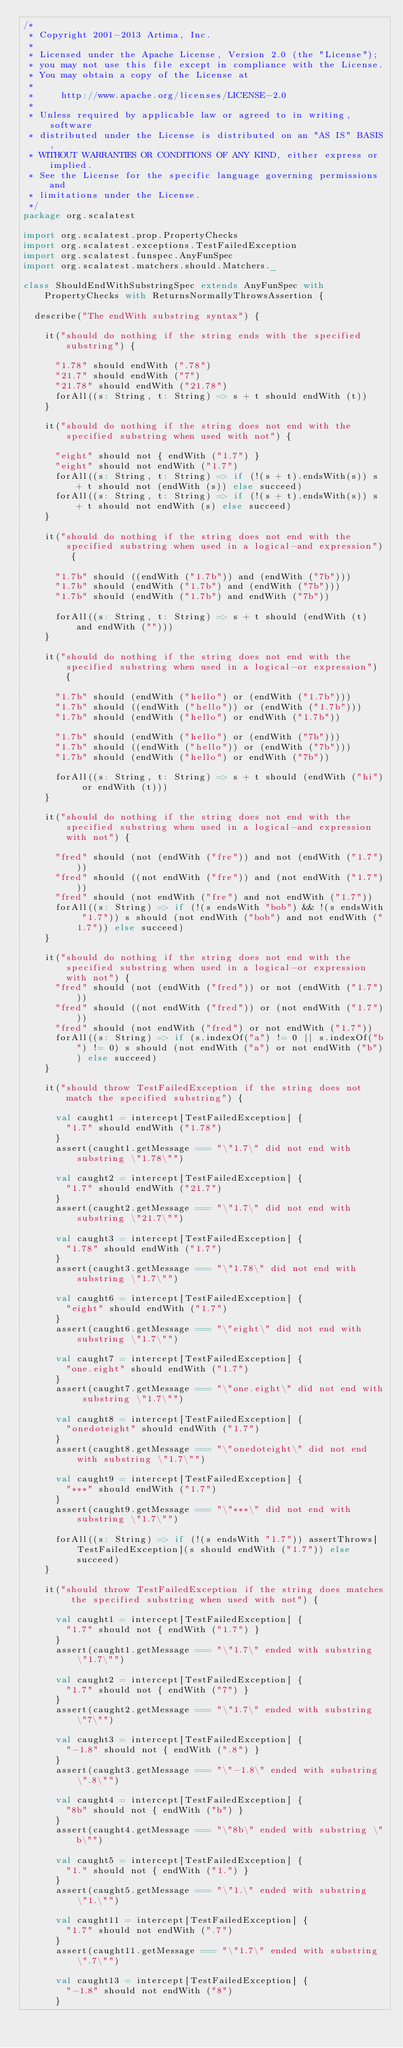<code> <loc_0><loc_0><loc_500><loc_500><_Scala_>/*
 * Copyright 2001-2013 Artima, Inc.
 *
 * Licensed under the Apache License, Version 2.0 (the "License");
 * you may not use this file except in compliance with the License.
 * You may obtain a copy of the License at
 *
 *     http://www.apache.org/licenses/LICENSE-2.0
 *
 * Unless required by applicable law or agreed to in writing, software
 * distributed under the License is distributed on an "AS IS" BASIS,
 * WITHOUT WARRANTIES OR CONDITIONS OF ANY KIND, either express or implied.
 * See the License for the specific language governing permissions and
 * limitations under the License.
 */
package org.scalatest

import org.scalatest.prop.PropertyChecks
import org.scalatest.exceptions.TestFailedException
import org.scalatest.funspec.AnyFunSpec
import org.scalatest.matchers.should.Matchers._

class ShouldEndWithSubstringSpec extends AnyFunSpec with PropertyChecks with ReturnsNormallyThrowsAssertion {

  describe("The endWith substring syntax") {

    it("should do nothing if the string ends with the specified substring") {

      "1.78" should endWith (".78")
      "21.7" should endWith ("7")
      "21.78" should endWith ("21.78")
      forAll((s: String, t: String) => s + t should endWith (t))
    }

    it("should do nothing if the string does not end with the specified substring when used with not") {

      "eight" should not { endWith ("1.7") }
      "eight" should not endWith ("1.7")
      forAll((s: String, t: String) => if (!(s + t).endsWith(s)) s + t should not (endWith (s)) else succeed)
      forAll((s: String, t: String) => if (!(s + t).endsWith(s)) s + t should not endWith (s) else succeed)
    }

    it("should do nothing if the string does not end with the specified substring when used in a logical-and expression") {

      "1.7b" should ((endWith ("1.7b")) and (endWith ("7b")))
      "1.7b" should (endWith ("1.7b") and (endWith ("7b")))
      "1.7b" should (endWith ("1.7b") and endWith ("7b"))

      forAll((s: String, t: String) => s + t should (endWith (t) and endWith ("")))
    }

    it("should do nothing if the string does not end with the specified substring when used in a logical-or expression") {

      "1.7b" should (endWith ("hello") or (endWith ("1.7b")))
      "1.7b" should ((endWith ("hello")) or (endWith ("1.7b")))
      "1.7b" should (endWith ("hello") or endWith ("1.7b"))

      "1.7b" should (endWith ("hello") or (endWith ("7b")))
      "1.7b" should ((endWith ("hello")) or (endWith ("7b")))
      "1.7b" should (endWith ("hello") or endWith ("7b"))

      forAll((s: String, t: String) => s + t should (endWith ("hi") or endWith (t)))
    }

    it("should do nothing if the string does not end with the specified substring when used in a logical-and expression with not") {

      "fred" should (not (endWith ("fre")) and not (endWith ("1.7")))
      "fred" should ((not endWith ("fre")) and (not endWith ("1.7")))
      "fred" should (not endWith ("fre") and not endWith ("1.7"))
      forAll((s: String) => if (!(s endsWith "bob") && !(s endsWith "1.7")) s should (not endWith ("bob") and not endWith ("1.7")) else succeed)
    }

    it("should do nothing if the string does not end with the specified substring when used in a logical-or expression with not") {
      "fred" should (not (endWith ("fred")) or not (endWith ("1.7")))
      "fred" should ((not endWith ("fred")) or (not endWith ("1.7")))
      "fred" should (not endWith ("fred") or not endWith ("1.7"))
      forAll((s: String) => if (s.indexOf("a") != 0 || s.indexOf("b") != 0) s should (not endWith ("a") or not endWith ("b")) else succeed)
    }

    it("should throw TestFailedException if the string does not match the specified substring") {

      val caught1 = intercept[TestFailedException] {
        "1.7" should endWith ("1.78")
      }
      assert(caught1.getMessage === "\"1.7\" did not end with substring \"1.78\"")

      val caught2 = intercept[TestFailedException] {
        "1.7" should endWith ("21.7")
      }
      assert(caught2.getMessage === "\"1.7\" did not end with substring \"21.7\"")

      val caught3 = intercept[TestFailedException] {
        "1.78" should endWith ("1.7")
      }
      assert(caught3.getMessage === "\"1.78\" did not end with substring \"1.7\"")

      val caught6 = intercept[TestFailedException] {
        "eight" should endWith ("1.7")
      }
      assert(caught6.getMessage === "\"eight\" did not end with substring \"1.7\"")

      val caught7 = intercept[TestFailedException] {
        "one.eight" should endWith ("1.7")
      }
      assert(caught7.getMessage === "\"one.eight\" did not end with substring \"1.7\"")

      val caught8 = intercept[TestFailedException] {
        "onedoteight" should endWith ("1.7")
      }
      assert(caught8.getMessage === "\"onedoteight\" did not end with substring \"1.7\"")

      val caught9 = intercept[TestFailedException] {
        "***" should endWith ("1.7")
      }
      assert(caught9.getMessage === "\"***\" did not end with substring \"1.7\"")

      forAll((s: String) => if (!(s endsWith "1.7")) assertThrows[TestFailedException](s should endWith ("1.7")) else succeed)
    }

    it("should throw TestFailedException if the string does matches the specified substring when used with not") {

      val caught1 = intercept[TestFailedException] {
        "1.7" should not { endWith ("1.7") }
      }
      assert(caught1.getMessage === "\"1.7\" ended with substring \"1.7\"")

      val caught2 = intercept[TestFailedException] {
        "1.7" should not { endWith ("7") }
      }
      assert(caught2.getMessage === "\"1.7\" ended with substring \"7\"")

      val caught3 = intercept[TestFailedException] {
        "-1.8" should not { endWith (".8") }
      }
      assert(caught3.getMessage === "\"-1.8\" ended with substring \".8\"")

      val caught4 = intercept[TestFailedException] {
        "8b" should not { endWith ("b") }
      }
      assert(caught4.getMessage === "\"8b\" ended with substring \"b\"")

      val caught5 = intercept[TestFailedException] {
        "1." should not { endWith ("1.") }
      }
      assert(caught5.getMessage === "\"1.\" ended with substring \"1.\"")

      val caught11 = intercept[TestFailedException] {
        "1.7" should not endWith (".7")
      }
      assert(caught11.getMessage === "\"1.7\" ended with substring \".7\"")

      val caught13 = intercept[TestFailedException] {
        "-1.8" should not endWith ("8")
      }</code> 